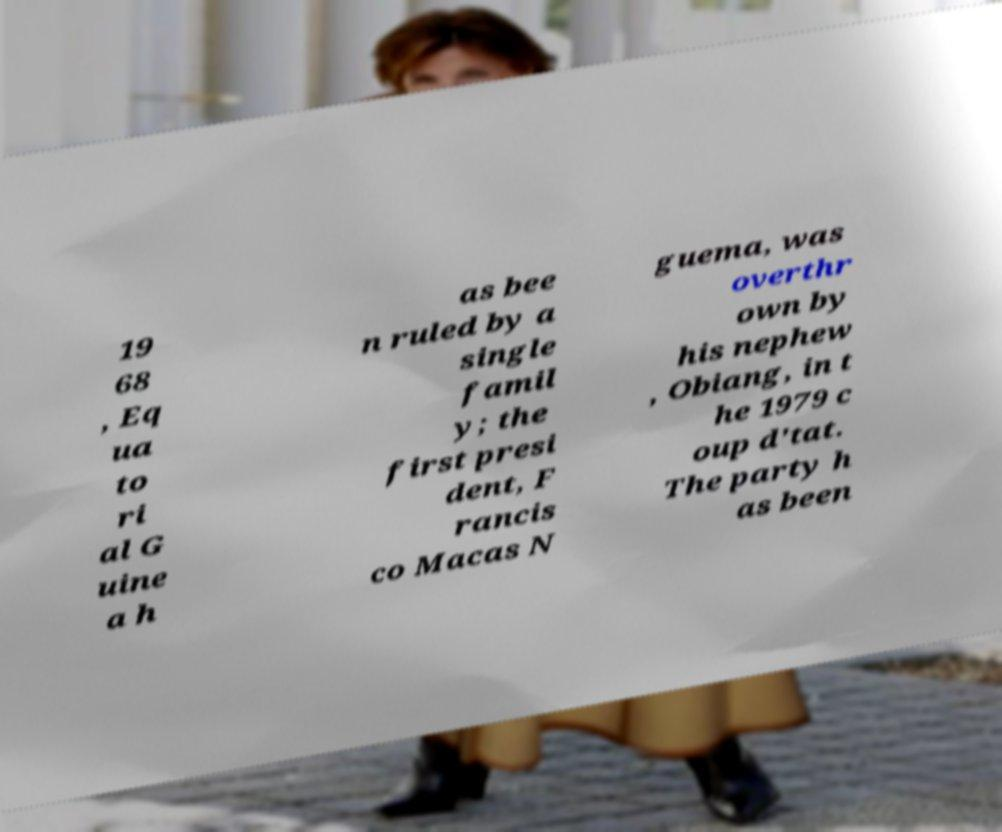There's text embedded in this image that I need extracted. Can you transcribe it verbatim? 19 68 , Eq ua to ri al G uine a h as bee n ruled by a single famil y; the first presi dent, F rancis co Macas N guema, was overthr own by his nephew , Obiang, in t he 1979 c oup d'tat. The party h as been 